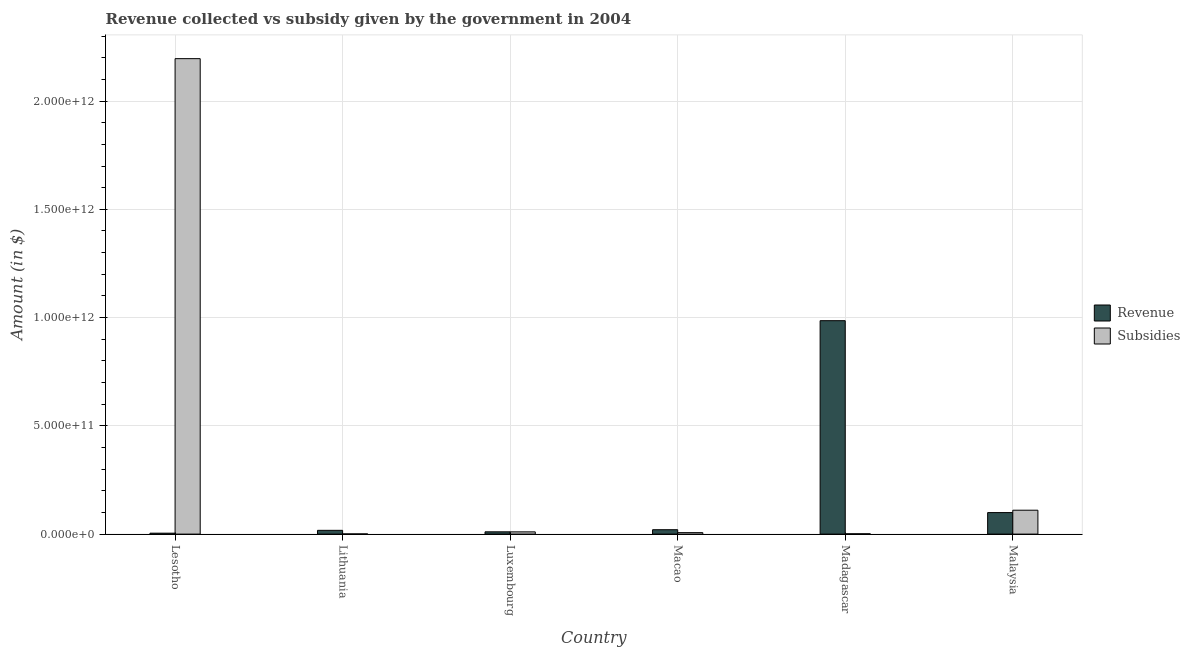How many different coloured bars are there?
Your answer should be compact. 2. How many groups of bars are there?
Your answer should be compact. 6. What is the label of the 6th group of bars from the left?
Your response must be concise. Malaysia. In how many cases, is the number of bars for a given country not equal to the number of legend labels?
Keep it short and to the point. 0. What is the amount of revenue collected in Madagascar?
Make the answer very short. 9.86e+11. Across all countries, what is the maximum amount of subsidies given?
Keep it short and to the point. 2.20e+12. Across all countries, what is the minimum amount of subsidies given?
Give a very brief answer. 8.99e+08. In which country was the amount of subsidies given maximum?
Provide a succinct answer. Lesotho. In which country was the amount of subsidies given minimum?
Your answer should be very brief. Lithuania. What is the total amount of revenue collected in the graph?
Your answer should be compact. 1.14e+12. What is the difference between the amount of subsidies given in Lithuania and that in Luxembourg?
Offer a terse response. -9.41e+09. What is the difference between the amount of subsidies given in Macao and the amount of revenue collected in Luxembourg?
Give a very brief answer. -3.75e+09. What is the average amount of revenue collected per country?
Offer a terse response. 1.90e+11. What is the difference between the amount of subsidies given and amount of revenue collected in Malaysia?
Offer a very short reply. 1.09e+1. What is the ratio of the amount of revenue collected in Lithuania to that in Malaysia?
Offer a terse response. 0.18. Is the amount of revenue collected in Lesotho less than that in Lithuania?
Give a very brief answer. Yes. Is the difference between the amount of revenue collected in Macao and Madagascar greater than the difference between the amount of subsidies given in Macao and Madagascar?
Provide a short and direct response. No. What is the difference between the highest and the second highest amount of revenue collected?
Keep it short and to the point. 8.86e+11. What is the difference between the highest and the lowest amount of subsidies given?
Give a very brief answer. 2.20e+12. In how many countries, is the amount of subsidies given greater than the average amount of subsidies given taken over all countries?
Offer a very short reply. 1. What does the 1st bar from the left in Macao represents?
Provide a short and direct response. Revenue. What does the 1st bar from the right in Lesotho represents?
Your answer should be very brief. Subsidies. How many bars are there?
Offer a terse response. 12. How many countries are there in the graph?
Make the answer very short. 6. What is the difference between two consecutive major ticks on the Y-axis?
Make the answer very short. 5.00e+11. Does the graph contain grids?
Provide a succinct answer. Yes. Where does the legend appear in the graph?
Ensure brevity in your answer.  Center right. How are the legend labels stacked?
Give a very brief answer. Vertical. What is the title of the graph?
Your answer should be very brief. Revenue collected vs subsidy given by the government in 2004. Does "Arms imports" appear as one of the legend labels in the graph?
Make the answer very short. No. What is the label or title of the Y-axis?
Provide a succinct answer. Amount (in $). What is the Amount (in $) in Revenue in Lesotho?
Give a very brief answer. 4.25e+09. What is the Amount (in $) in Subsidies in Lesotho?
Give a very brief answer. 2.20e+12. What is the Amount (in $) of Revenue in Lithuania?
Make the answer very short. 1.74e+1. What is the Amount (in $) of Subsidies in Lithuania?
Ensure brevity in your answer.  8.99e+08. What is the Amount (in $) in Revenue in Luxembourg?
Give a very brief answer. 1.05e+1. What is the Amount (in $) in Subsidies in Luxembourg?
Keep it short and to the point. 1.03e+1. What is the Amount (in $) of Revenue in Macao?
Give a very brief answer. 2.02e+1. What is the Amount (in $) of Subsidies in Macao?
Provide a short and direct response. 6.78e+09. What is the Amount (in $) in Revenue in Madagascar?
Offer a very short reply. 9.86e+11. What is the Amount (in $) of Subsidies in Madagascar?
Keep it short and to the point. 1.49e+09. What is the Amount (in $) in Revenue in Malaysia?
Provide a succinct answer. 9.94e+1. What is the Amount (in $) of Subsidies in Malaysia?
Offer a terse response. 1.10e+11. Across all countries, what is the maximum Amount (in $) in Revenue?
Offer a terse response. 9.86e+11. Across all countries, what is the maximum Amount (in $) of Subsidies?
Provide a succinct answer. 2.20e+12. Across all countries, what is the minimum Amount (in $) of Revenue?
Give a very brief answer. 4.25e+09. Across all countries, what is the minimum Amount (in $) in Subsidies?
Give a very brief answer. 8.99e+08. What is the total Amount (in $) of Revenue in the graph?
Your answer should be compact. 1.14e+12. What is the total Amount (in $) of Subsidies in the graph?
Your answer should be compact. 2.33e+12. What is the difference between the Amount (in $) in Revenue in Lesotho and that in Lithuania?
Give a very brief answer. -1.31e+1. What is the difference between the Amount (in $) in Subsidies in Lesotho and that in Lithuania?
Your answer should be very brief. 2.20e+12. What is the difference between the Amount (in $) of Revenue in Lesotho and that in Luxembourg?
Provide a short and direct response. -6.28e+09. What is the difference between the Amount (in $) of Subsidies in Lesotho and that in Luxembourg?
Ensure brevity in your answer.  2.19e+12. What is the difference between the Amount (in $) of Revenue in Lesotho and that in Macao?
Give a very brief answer. -1.60e+1. What is the difference between the Amount (in $) of Subsidies in Lesotho and that in Macao?
Ensure brevity in your answer.  2.19e+12. What is the difference between the Amount (in $) of Revenue in Lesotho and that in Madagascar?
Keep it short and to the point. -9.81e+11. What is the difference between the Amount (in $) of Subsidies in Lesotho and that in Madagascar?
Your answer should be compact. 2.19e+12. What is the difference between the Amount (in $) in Revenue in Lesotho and that in Malaysia?
Your answer should be compact. -9.51e+1. What is the difference between the Amount (in $) of Subsidies in Lesotho and that in Malaysia?
Give a very brief answer. 2.09e+12. What is the difference between the Amount (in $) of Revenue in Lithuania and that in Luxembourg?
Give a very brief answer. 6.87e+09. What is the difference between the Amount (in $) in Subsidies in Lithuania and that in Luxembourg?
Keep it short and to the point. -9.41e+09. What is the difference between the Amount (in $) of Revenue in Lithuania and that in Macao?
Offer a very short reply. -2.85e+09. What is the difference between the Amount (in $) in Subsidies in Lithuania and that in Macao?
Give a very brief answer. -5.88e+09. What is the difference between the Amount (in $) of Revenue in Lithuania and that in Madagascar?
Make the answer very short. -9.68e+11. What is the difference between the Amount (in $) of Subsidies in Lithuania and that in Madagascar?
Give a very brief answer. -5.91e+08. What is the difference between the Amount (in $) in Revenue in Lithuania and that in Malaysia?
Keep it short and to the point. -8.20e+1. What is the difference between the Amount (in $) in Subsidies in Lithuania and that in Malaysia?
Provide a succinct answer. -1.09e+11. What is the difference between the Amount (in $) of Revenue in Luxembourg and that in Macao?
Your response must be concise. -9.72e+09. What is the difference between the Amount (in $) of Subsidies in Luxembourg and that in Macao?
Give a very brief answer. 3.53e+09. What is the difference between the Amount (in $) of Revenue in Luxembourg and that in Madagascar?
Your answer should be very brief. -9.75e+11. What is the difference between the Amount (in $) in Subsidies in Luxembourg and that in Madagascar?
Give a very brief answer. 8.82e+09. What is the difference between the Amount (in $) in Revenue in Luxembourg and that in Malaysia?
Your response must be concise. -8.89e+1. What is the difference between the Amount (in $) in Subsidies in Luxembourg and that in Malaysia?
Keep it short and to the point. -1.00e+11. What is the difference between the Amount (in $) of Revenue in Macao and that in Madagascar?
Give a very brief answer. -9.65e+11. What is the difference between the Amount (in $) of Subsidies in Macao and that in Madagascar?
Offer a very short reply. 5.29e+09. What is the difference between the Amount (in $) in Revenue in Macao and that in Malaysia?
Provide a succinct answer. -7.91e+1. What is the difference between the Amount (in $) in Subsidies in Macao and that in Malaysia?
Ensure brevity in your answer.  -1.04e+11. What is the difference between the Amount (in $) in Revenue in Madagascar and that in Malaysia?
Ensure brevity in your answer.  8.86e+11. What is the difference between the Amount (in $) of Subsidies in Madagascar and that in Malaysia?
Your answer should be very brief. -1.09e+11. What is the difference between the Amount (in $) in Revenue in Lesotho and the Amount (in $) in Subsidies in Lithuania?
Offer a very short reply. 3.35e+09. What is the difference between the Amount (in $) of Revenue in Lesotho and the Amount (in $) of Subsidies in Luxembourg?
Offer a very short reply. -6.06e+09. What is the difference between the Amount (in $) in Revenue in Lesotho and the Amount (in $) in Subsidies in Macao?
Offer a very short reply. -2.53e+09. What is the difference between the Amount (in $) in Revenue in Lesotho and the Amount (in $) in Subsidies in Madagascar?
Your response must be concise. 2.76e+09. What is the difference between the Amount (in $) of Revenue in Lesotho and the Amount (in $) of Subsidies in Malaysia?
Your answer should be compact. -1.06e+11. What is the difference between the Amount (in $) in Revenue in Lithuania and the Amount (in $) in Subsidies in Luxembourg?
Keep it short and to the point. 7.09e+09. What is the difference between the Amount (in $) of Revenue in Lithuania and the Amount (in $) of Subsidies in Macao?
Your answer should be very brief. 1.06e+1. What is the difference between the Amount (in $) of Revenue in Lithuania and the Amount (in $) of Subsidies in Madagascar?
Your response must be concise. 1.59e+1. What is the difference between the Amount (in $) of Revenue in Lithuania and the Amount (in $) of Subsidies in Malaysia?
Your response must be concise. -9.29e+1. What is the difference between the Amount (in $) of Revenue in Luxembourg and the Amount (in $) of Subsidies in Macao?
Make the answer very short. 3.75e+09. What is the difference between the Amount (in $) of Revenue in Luxembourg and the Amount (in $) of Subsidies in Madagascar?
Your response must be concise. 9.04e+09. What is the difference between the Amount (in $) in Revenue in Luxembourg and the Amount (in $) in Subsidies in Malaysia?
Make the answer very short. -9.98e+1. What is the difference between the Amount (in $) of Revenue in Macao and the Amount (in $) of Subsidies in Madagascar?
Keep it short and to the point. 1.88e+1. What is the difference between the Amount (in $) of Revenue in Macao and the Amount (in $) of Subsidies in Malaysia?
Ensure brevity in your answer.  -9.01e+1. What is the difference between the Amount (in $) of Revenue in Madagascar and the Amount (in $) of Subsidies in Malaysia?
Ensure brevity in your answer.  8.75e+11. What is the average Amount (in $) of Revenue per country?
Offer a very short reply. 1.90e+11. What is the average Amount (in $) of Subsidies per country?
Your answer should be very brief. 3.88e+11. What is the difference between the Amount (in $) of Revenue and Amount (in $) of Subsidies in Lesotho?
Ensure brevity in your answer.  -2.19e+12. What is the difference between the Amount (in $) in Revenue and Amount (in $) in Subsidies in Lithuania?
Keep it short and to the point. 1.65e+1. What is the difference between the Amount (in $) in Revenue and Amount (in $) in Subsidies in Luxembourg?
Keep it short and to the point. 2.16e+08. What is the difference between the Amount (in $) in Revenue and Amount (in $) in Subsidies in Macao?
Offer a terse response. 1.35e+1. What is the difference between the Amount (in $) of Revenue and Amount (in $) of Subsidies in Madagascar?
Ensure brevity in your answer.  9.84e+11. What is the difference between the Amount (in $) in Revenue and Amount (in $) in Subsidies in Malaysia?
Offer a terse response. -1.09e+1. What is the ratio of the Amount (in $) of Revenue in Lesotho to that in Lithuania?
Your answer should be compact. 0.24. What is the ratio of the Amount (in $) in Subsidies in Lesotho to that in Lithuania?
Your response must be concise. 2442.01. What is the ratio of the Amount (in $) in Revenue in Lesotho to that in Luxembourg?
Your answer should be very brief. 0.4. What is the ratio of the Amount (in $) in Subsidies in Lesotho to that in Luxembourg?
Ensure brevity in your answer.  212.94. What is the ratio of the Amount (in $) of Revenue in Lesotho to that in Macao?
Provide a short and direct response. 0.21. What is the ratio of the Amount (in $) in Subsidies in Lesotho to that in Macao?
Your answer should be compact. 323.85. What is the ratio of the Amount (in $) of Revenue in Lesotho to that in Madagascar?
Make the answer very short. 0. What is the ratio of the Amount (in $) of Subsidies in Lesotho to that in Madagascar?
Your answer should be very brief. 1473.38. What is the ratio of the Amount (in $) in Revenue in Lesotho to that in Malaysia?
Ensure brevity in your answer.  0.04. What is the ratio of the Amount (in $) in Subsidies in Lesotho to that in Malaysia?
Your answer should be compact. 19.9. What is the ratio of the Amount (in $) of Revenue in Lithuania to that in Luxembourg?
Ensure brevity in your answer.  1.65. What is the ratio of the Amount (in $) of Subsidies in Lithuania to that in Luxembourg?
Keep it short and to the point. 0.09. What is the ratio of the Amount (in $) in Revenue in Lithuania to that in Macao?
Provide a succinct answer. 0.86. What is the ratio of the Amount (in $) of Subsidies in Lithuania to that in Macao?
Make the answer very short. 0.13. What is the ratio of the Amount (in $) in Revenue in Lithuania to that in Madagascar?
Your answer should be compact. 0.02. What is the ratio of the Amount (in $) of Subsidies in Lithuania to that in Madagascar?
Give a very brief answer. 0.6. What is the ratio of the Amount (in $) in Revenue in Lithuania to that in Malaysia?
Keep it short and to the point. 0.18. What is the ratio of the Amount (in $) in Subsidies in Lithuania to that in Malaysia?
Give a very brief answer. 0.01. What is the ratio of the Amount (in $) of Revenue in Luxembourg to that in Macao?
Provide a succinct answer. 0.52. What is the ratio of the Amount (in $) of Subsidies in Luxembourg to that in Macao?
Your answer should be very brief. 1.52. What is the ratio of the Amount (in $) of Revenue in Luxembourg to that in Madagascar?
Give a very brief answer. 0.01. What is the ratio of the Amount (in $) of Subsidies in Luxembourg to that in Madagascar?
Make the answer very short. 6.92. What is the ratio of the Amount (in $) of Revenue in Luxembourg to that in Malaysia?
Provide a succinct answer. 0.11. What is the ratio of the Amount (in $) of Subsidies in Luxembourg to that in Malaysia?
Keep it short and to the point. 0.09. What is the ratio of the Amount (in $) of Revenue in Macao to that in Madagascar?
Your answer should be compact. 0.02. What is the ratio of the Amount (in $) of Subsidies in Macao to that in Madagascar?
Offer a very short reply. 4.55. What is the ratio of the Amount (in $) of Revenue in Macao to that in Malaysia?
Provide a succinct answer. 0.2. What is the ratio of the Amount (in $) of Subsidies in Macao to that in Malaysia?
Offer a terse response. 0.06. What is the ratio of the Amount (in $) of Revenue in Madagascar to that in Malaysia?
Make the answer very short. 9.92. What is the ratio of the Amount (in $) of Subsidies in Madagascar to that in Malaysia?
Provide a short and direct response. 0.01. What is the difference between the highest and the second highest Amount (in $) of Revenue?
Offer a terse response. 8.86e+11. What is the difference between the highest and the second highest Amount (in $) of Subsidies?
Offer a very short reply. 2.09e+12. What is the difference between the highest and the lowest Amount (in $) of Revenue?
Your answer should be very brief. 9.81e+11. What is the difference between the highest and the lowest Amount (in $) in Subsidies?
Provide a succinct answer. 2.20e+12. 